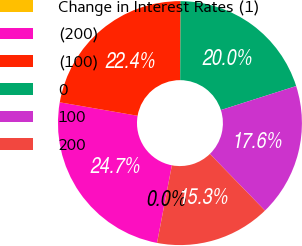Convert chart to OTSL. <chart><loc_0><loc_0><loc_500><loc_500><pie_chart><fcel>Change in Interest Rates (1)<fcel>(200)<fcel>(100)<fcel>0<fcel>100<fcel>200<nl><fcel>0.0%<fcel>24.72%<fcel>22.36%<fcel>20.0%<fcel>17.64%<fcel>15.28%<nl></chart> 